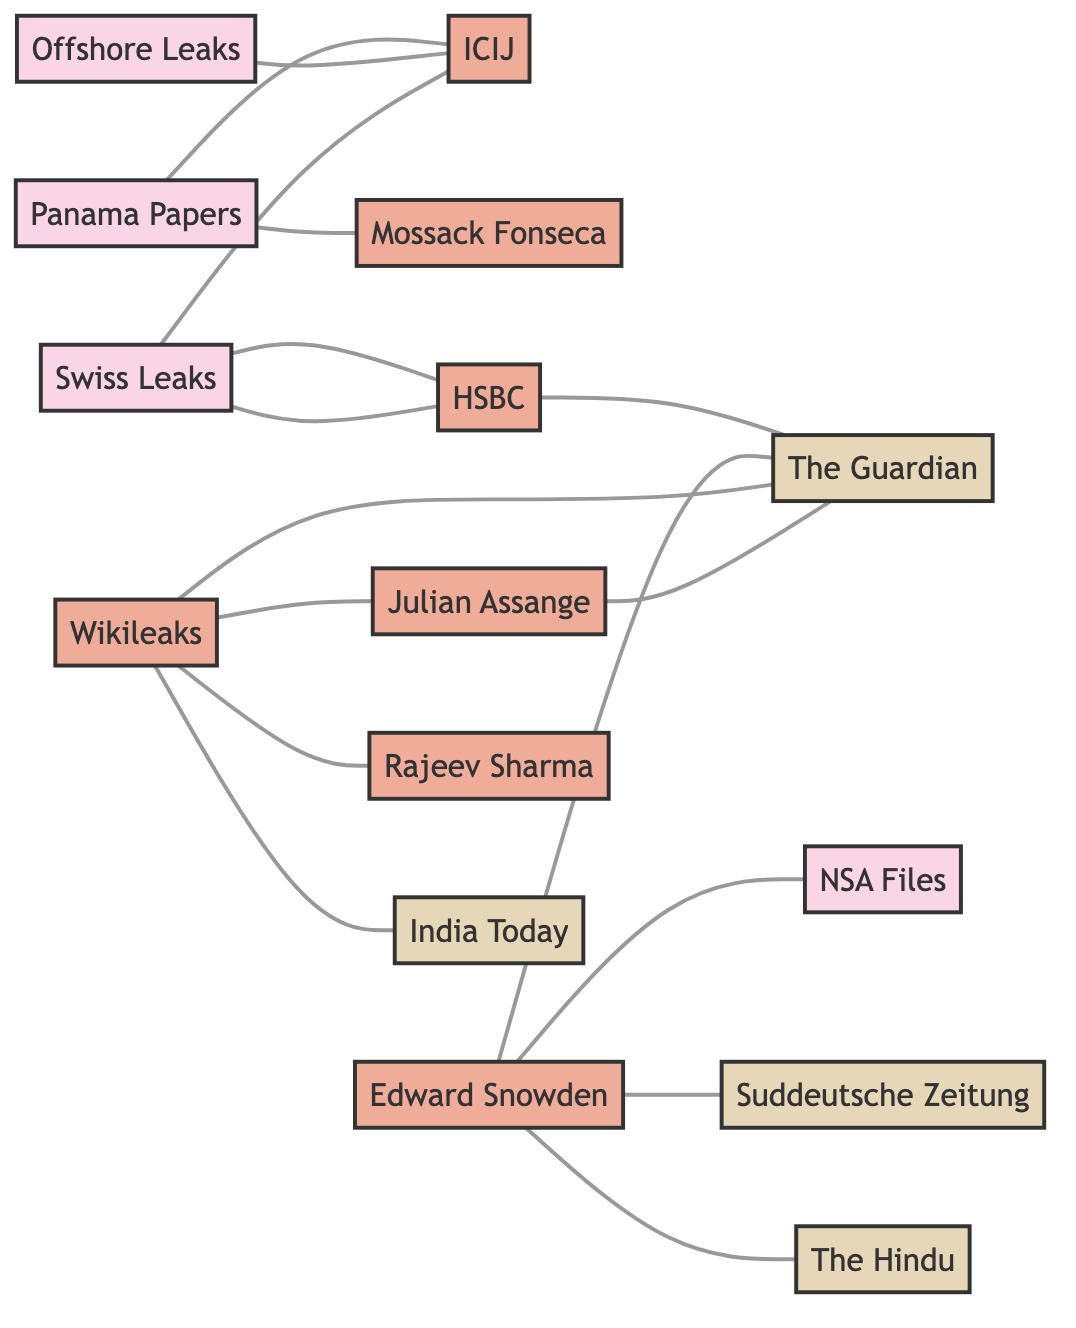What is the total number of nodes in the diagram? The diagram consists of a list of various entities (nodes) related to investigative reports and their sources. By counting the nodes listed in the data, we find that there are 15 distinct nodes present in the graph.
Answer: 15 Which report is directly linked to the ICIJ? The diagram displays edges (connections) between nodes. The edge connecting the 'Panama Papers' node (1) to the 'ICIJ' node (2) indicates a direct relationship between these two entities.
Answer: Panama Papers How many edges are connected to the node representing ‘HSBC’? To determine the number of edges connected to the 'HSBC' node (6), we count the connections it has in the data. 'HSBC' connects to 'Swiss Leaks' (5) and 'The Guardian' (7), giving it a total of 2 edges.
Answer: 2 Which report is associated with the key source Edward Snowden? In the diagram, the node for 'Edward Snowden' (9) has edges connecting it to three nodes: 'NSA Files' (10), 'The Guardian' (7), and 'Suddeutsche Zeitung' (8). Among these connections, 'NSA Files' is specifically labeled as a report associated with Edward Snowden.
Answer: NSA Files What is the relationship between 'Wikileaks' and 'Julian Assange'? By examining the connections (edges) in the diagram, we find that 'Wikileaks' (11) has a direct connection to 'Julian Assange' (12), indicating that they share a mutual relationship as depicted by the edge between these nodes.
Answer: They are connected Which media outlet is related to both 'HSBC' and 'Swiss Leaks'? Analyzing the edges from 'HSBC' (6), we see that it is connected to both 'The Guardian' (7) and 'Swiss Leaks' (5). From these, 'Swiss Leaks' also connects to 'ICIJ' (2), and though 'The Guardian' is the media outlet that connects to both 'HSBC' and 'Swiss Leaks', it's only listed as the media outlet linked with 'HSBC'.
Answer: The Guardian 